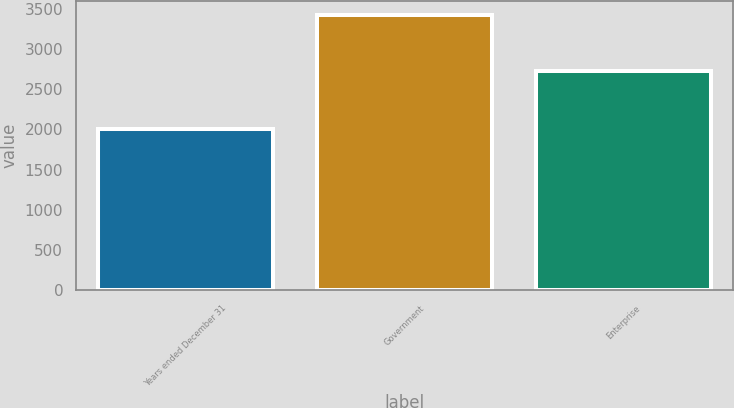Convert chart to OTSL. <chart><loc_0><loc_0><loc_500><loc_500><bar_chart><fcel>Years ended December 31<fcel>Government<fcel>Enterprise<nl><fcel>2010<fcel>3424<fcel>2724<nl></chart> 